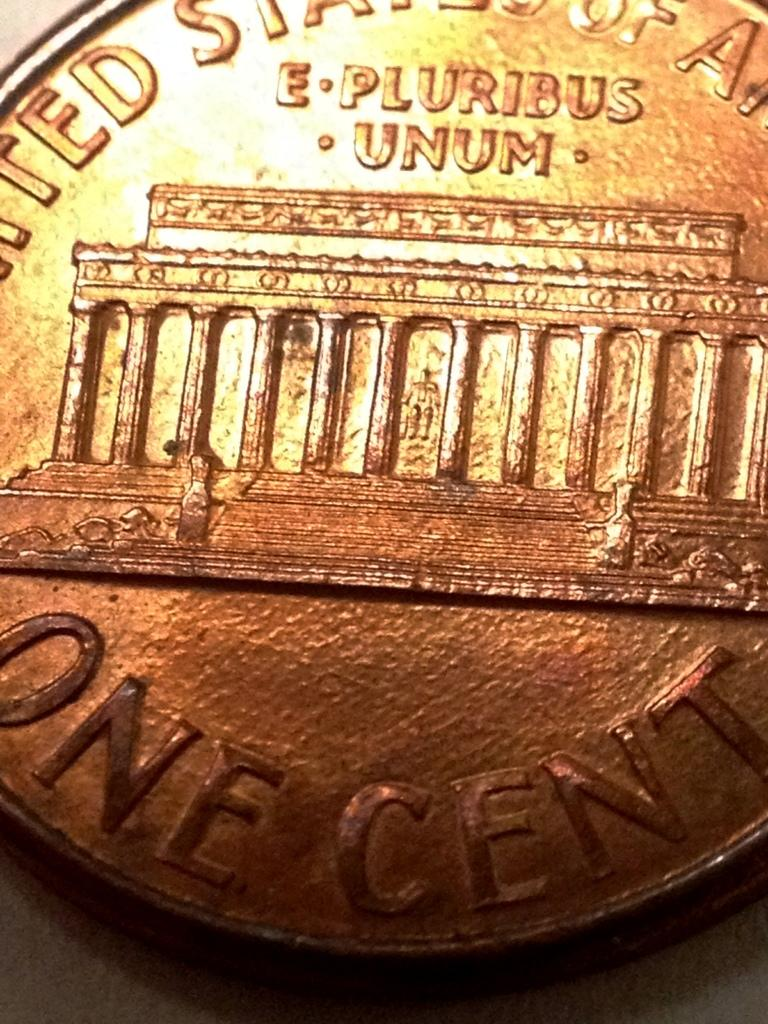<image>
Describe the image concisely. a copper coin that says one cent on the bottom of it 